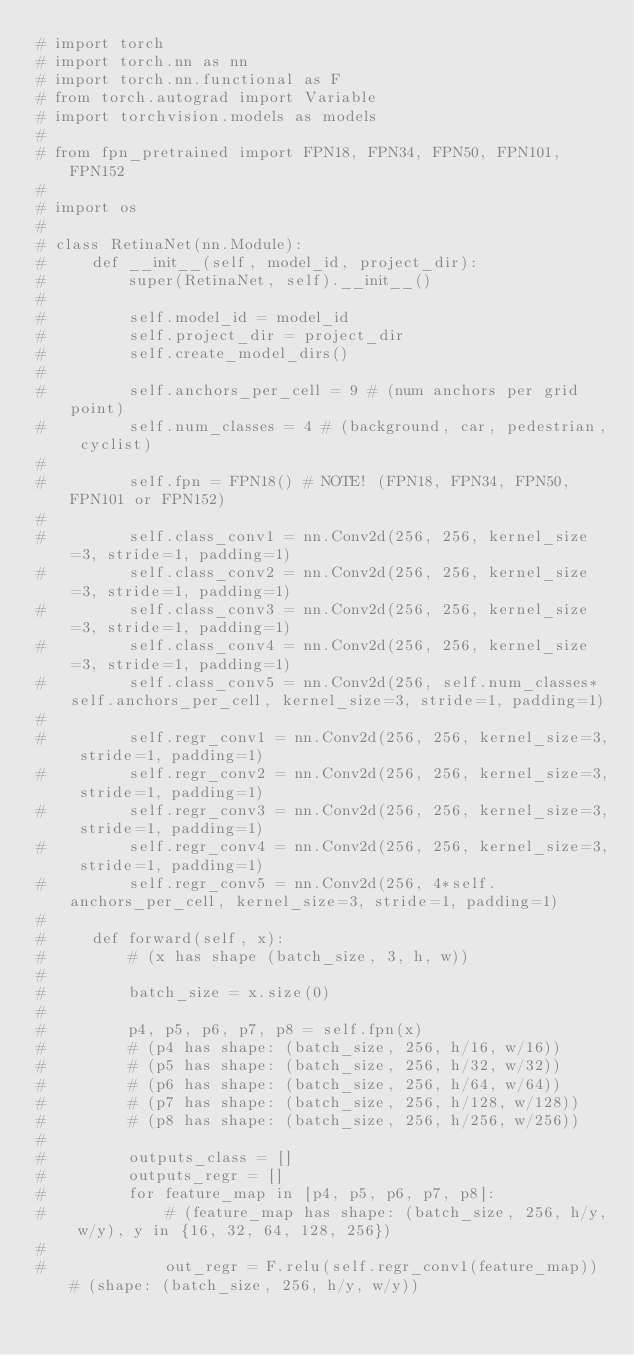Convert code to text. <code><loc_0><loc_0><loc_500><loc_500><_Python_># import torch
# import torch.nn as nn
# import torch.nn.functional as F
# from torch.autograd import Variable
# import torchvision.models as models
#
# from fpn_pretrained import FPN18, FPN34, FPN50, FPN101, FPN152
#
# import os
#
# class RetinaNet(nn.Module):
#     def __init__(self, model_id, project_dir):
#         super(RetinaNet, self).__init__()
#
#         self.model_id = model_id
#         self.project_dir = project_dir
#         self.create_model_dirs()
#
#         self.anchors_per_cell = 9 # (num anchors per grid point)
#         self.num_classes = 4 # (background, car, pedestrian, cyclist)
#
#         self.fpn = FPN18() # NOTE! (FPN18, FPN34, FPN50, FPN101 or FPN152)
#
#         self.class_conv1 = nn.Conv2d(256, 256, kernel_size=3, stride=1, padding=1)
#         self.class_conv2 = nn.Conv2d(256, 256, kernel_size=3, stride=1, padding=1)
#         self.class_conv3 = nn.Conv2d(256, 256, kernel_size=3, stride=1, padding=1)
#         self.class_conv4 = nn.Conv2d(256, 256, kernel_size=3, stride=1, padding=1)
#         self.class_conv5 = nn.Conv2d(256, self.num_classes*self.anchors_per_cell, kernel_size=3, stride=1, padding=1)
#
#         self.regr_conv1 = nn.Conv2d(256, 256, kernel_size=3, stride=1, padding=1)
#         self.regr_conv2 = nn.Conv2d(256, 256, kernel_size=3, stride=1, padding=1)
#         self.regr_conv3 = nn.Conv2d(256, 256, kernel_size=3, stride=1, padding=1)
#         self.regr_conv4 = nn.Conv2d(256, 256, kernel_size=3, stride=1, padding=1)
#         self.regr_conv5 = nn.Conv2d(256, 4*self.anchors_per_cell, kernel_size=3, stride=1, padding=1)
#
#     def forward(self, x):
#         # (x has shape (batch_size, 3, h, w))
#
#         batch_size = x.size(0)
#
#         p4, p5, p6, p7, p8 = self.fpn(x)
#         # (p4 has shape: (batch_size, 256, h/16, w/16))
#         # (p5 has shape: (batch_size, 256, h/32, w/32))
#         # (p6 has shape: (batch_size, 256, h/64, w/64))
#         # (p7 has shape: (batch_size, 256, h/128, w/128))
#         # (p8 has shape: (batch_size, 256, h/256, w/256))
#
#         outputs_class = []
#         outputs_regr = []
#         for feature_map in [p4, p5, p6, p7, p8]:
#             # (feature_map has shape: (batch_size, 256, h/y, w/y), y in {16, 32, 64, 128, 256})
#
#             out_regr = F.relu(self.regr_conv1(feature_map)) # (shape: (batch_size, 256, h/y, w/y))</code> 